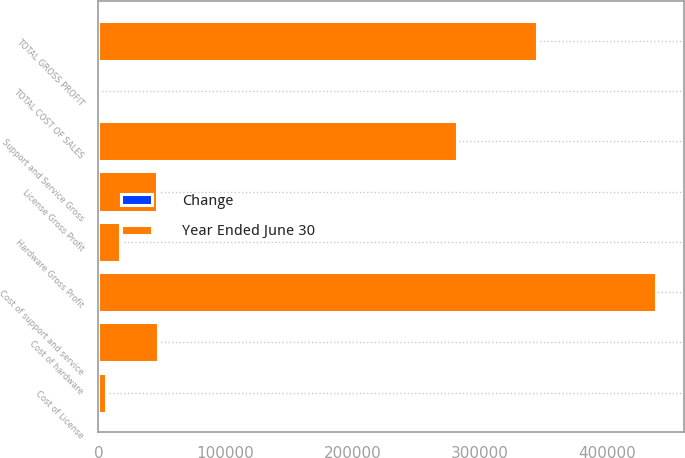Convert chart. <chart><loc_0><loc_0><loc_500><loc_500><stacked_bar_chart><ecel><fcel>Cost of License<fcel>License Gross Profit<fcel>Cost of support and service<fcel>Support and Service Gross<fcel>Cost of hardware<fcel>Hardware Gross Profit<fcel>TOTAL COST OF SALES<fcel>TOTAL GROSS PROFIT<nl><fcel>Year Ended June 30<fcel>5827<fcel>46398<fcel>438476<fcel>282028<fcel>47163<fcel>16694<fcel>23<fcel>345120<nl><fcel>Change<fcel>15<fcel>10<fcel>14<fcel>23<fcel>12<fcel>14<fcel>10<fcel>15<nl></chart> 